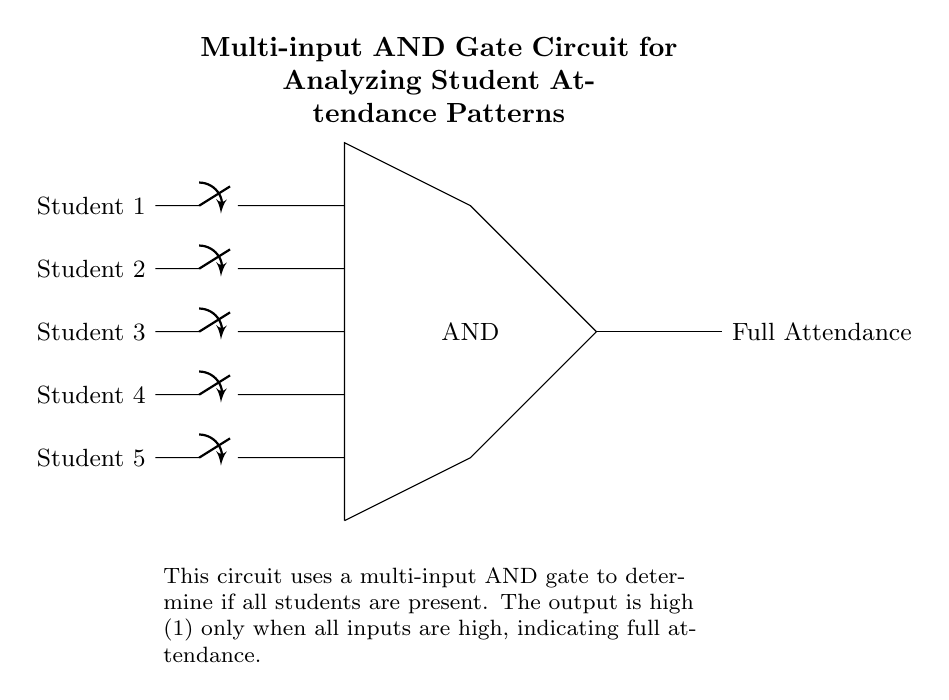What is the function of the component labeled "AND"? The component labeled "AND" is a multi-input logical gate that outputs a high signal only when all of its inputs are high. This means that it checks the attendance of all students and determines if they are all present.
Answer: AND How many students are represented in this circuit? The circuit diagram indicates five switches, each representing one student. The arrangement of the switches shows that there are inputs from Student 1 through Student 5.
Answer: Five What will the output be if one student is absent? If one student is absent, then at least one input to the AND gate will be low (0), resulting in a low output (0) from the AND gate since it requires all inputs to be high to produce a high output.
Answer: Zero What does a high output signify in this circuit? A high output from the AND gate signifies that all students are present, meaning full attendance has been achieved. The AND gate essentially functions as a mechanism for verifying completeness of attendance.
Answer: Full Attendance What type of logic gate is used in the circuit? The circuit uses a multi-input AND gate, which is a type of logic gate that combines multiple inputs and outputs one signal only when all inputs are high. This characteristic is fundamental in attendance verification scenarios.
Answer: Multi-input AND gate What is the purpose of the switches in this circuit? The switches serve as input devices that can be toggled to represent the attendance status of each student. If a switch is in the "on" position, that indicates the student is present; if "off," they are absent.
Answer: Attendance status What condition must be met for the circuit to show full attendance? For the circuit to show full attendance, all five switches must be in the "on" position, meaning every student must be present for the AND gate to output a high signal.
Answer: All switches on 